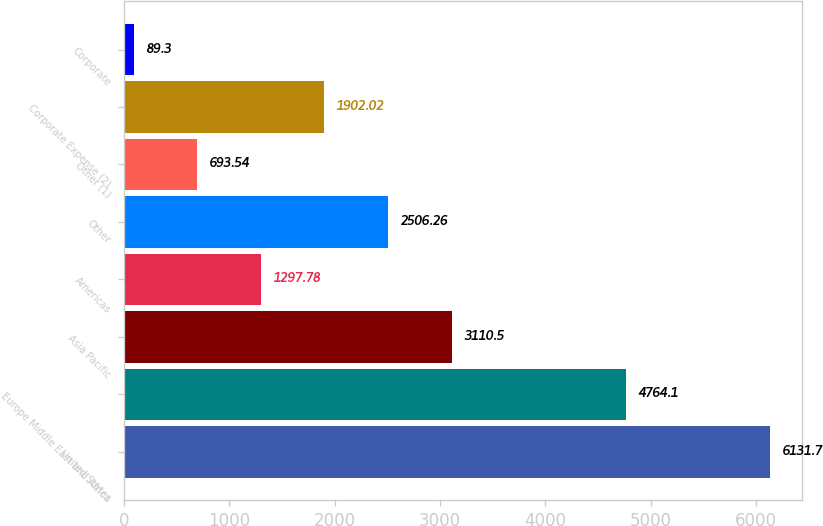<chart> <loc_0><loc_0><loc_500><loc_500><bar_chart><fcel>United States<fcel>Europe Middle East and Africa<fcel>Asia Pacific<fcel>Americas<fcel>Other<fcel>Other (1)<fcel>Corporate Expense (2)<fcel>Corporate<nl><fcel>6131.7<fcel>4764.1<fcel>3110.5<fcel>1297.78<fcel>2506.26<fcel>693.54<fcel>1902.02<fcel>89.3<nl></chart> 